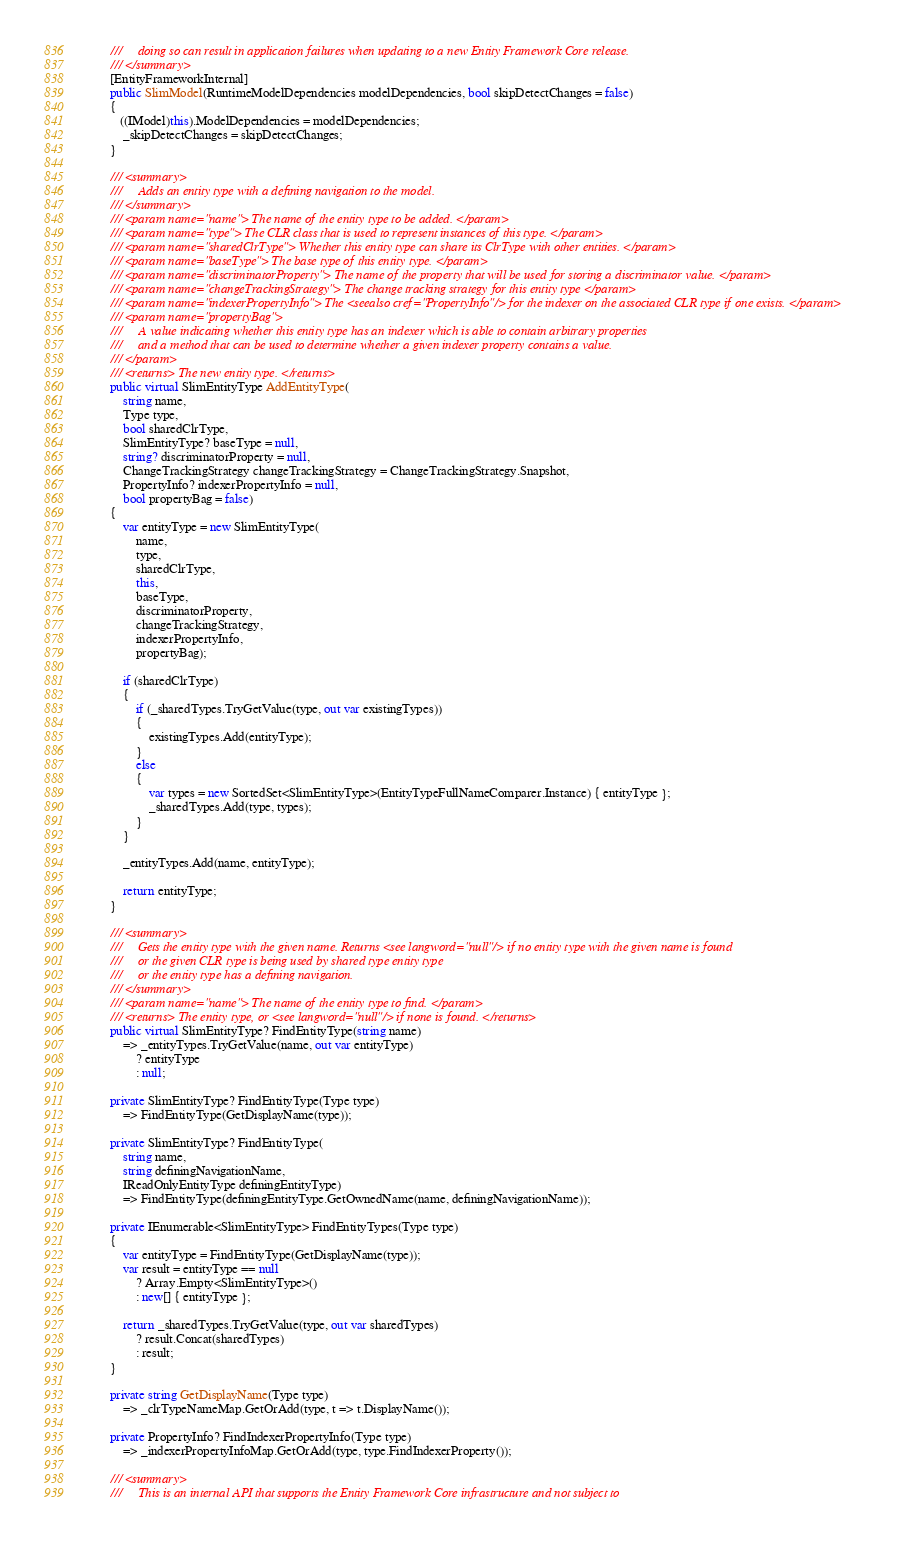Convert code to text. <code><loc_0><loc_0><loc_500><loc_500><_C#_>        ///     doing so can result in application failures when updating to a new Entity Framework Core release.
        /// </summary>
        [EntityFrameworkInternal]
        public SlimModel(RuntimeModelDependencies modelDependencies, bool skipDetectChanges = false)
        {
           ((IModel)this).ModelDependencies = modelDependencies;
            _skipDetectChanges = skipDetectChanges;
        }

        /// <summary>
        ///     Adds an entity type with a defining navigation to the model.
        /// </summary>
        /// <param name="name"> The name of the entity type to be added. </param>
        /// <param name="type"> The CLR class that is used to represent instances of this type. </param>
        /// <param name="sharedClrType"> Whether this entity type can share its ClrType with other entities. </param>
        /// <param name="baseType"> The base type of this entity type. </param>
        /// <param name="discriminatorProperty"> The name of the property that will be used for storing a discriminator value. </param>
        /// <param name="changeTrackingStrategy"> The change tracking strategy for this entity type </param>
        /// <param name="indexerPropertyInfo"> The <seealso cref="PropertyInfo"/> for the indexer on the associated CLR type if one exists. </param>
        /// <param name="propertyBag">
        ///     A value indicating whether this entity type has an indexer which is able to contain arbitrary properties
        ///     and a method that can be used to determine whether a given indexer property contains a value.
        /// </param>
        /// <returns> The new entity type. </returns>
        public virtual SlimEntityType AddEntityType(
            string name,
            Type type,
            bool sharedClrType,
            SlimEntityType? baseType = null,
            string? discriminatorProperty = null,
            ChangeTrackingStrategy changeTrackingStrategy = ChangeTrackingStrategy.Snapshot,
            PropertyInfo? indexerPropertyInfo = null,
            bool propertyBag = false)
        {
            var entityType = new SlimEntityType(
                name,
                type,
                sharedClrType,
                this,
                baseType,
                discriminatorProperty,
                changeTrackingStrategy,
                indexerPropertyInfo,
                propertyBag);

            if (sharedClrType)
            {
                if (_sharedTypes.TryGetValue(type, out var existingTypes))
                {
                    existingTypes.Add(entityType);
                }
                else
                {
                    var types = new SortedSet<SlimEntityType>(EntityTypeFullNameComparer.Instance) { entityType };
                    _sharedTypes.Add(type, types);
                }
            }

            _entityTypes.Add(name, entityType);

            return entityType;
        }

        /// <summary>
        ///     Gets the entity type with the given name. Returns <see langword="null"/> if no entity type with the given name is found
        ///     or the given CLR type is being used by shared type entity type
        ///     or the entity type has a defining navigation.
        /// </summary>
        /// <param name="name"> The name of the entity type to find. </param>
        /// <returns> The entity type, or <see langword="null"/> if none is found. </returns>
        public virtual SlimEntityType? FindEntityType(string name)
            => _entityTypes.TryGetValue(name, out var entityType)
                ? entityType
                : null;

        private SlimEntityType? FindEntityType(Type type)
            => FindEntityType(GetDisplayName(type));

        private SlimEntityType? FindEntityType(
            string name,
            string definingNavigationName,
            IReadOnlyEntityType definingEntityType)
            => FindEntityType(definingEntityType.GetOwnedName(name, definingNavigationName));

        private IEnumerable<SlimEntityType> FindEntityTypes(Type type)
        {
            var entityType = FindEntityType(GetDisplayName(type));
            var result = entityType == null
                ? Array.Empty<SlimEntityType>()
                : new[] { entityType };

            return _sharedTypes.TryGetValue(type, out var sharedTypes)
                ? result.Concat(sharedTypes)
                : result;
        }

        private string GetDisplayName(Type type)
            => _clrTypeNameMap.GetOrAdd(type, t => t.DisplayName());

        private PropertyInfo? FindIndexerPropertyInfo(Type type)
            => _indexerPropertyInfoMap.GetOrAdd(type, type.FindIndexerProperty());

        /// <summary>
        ///     This is an internal API that supports the Entity Framework Core infrastructure and not subject to</code> 